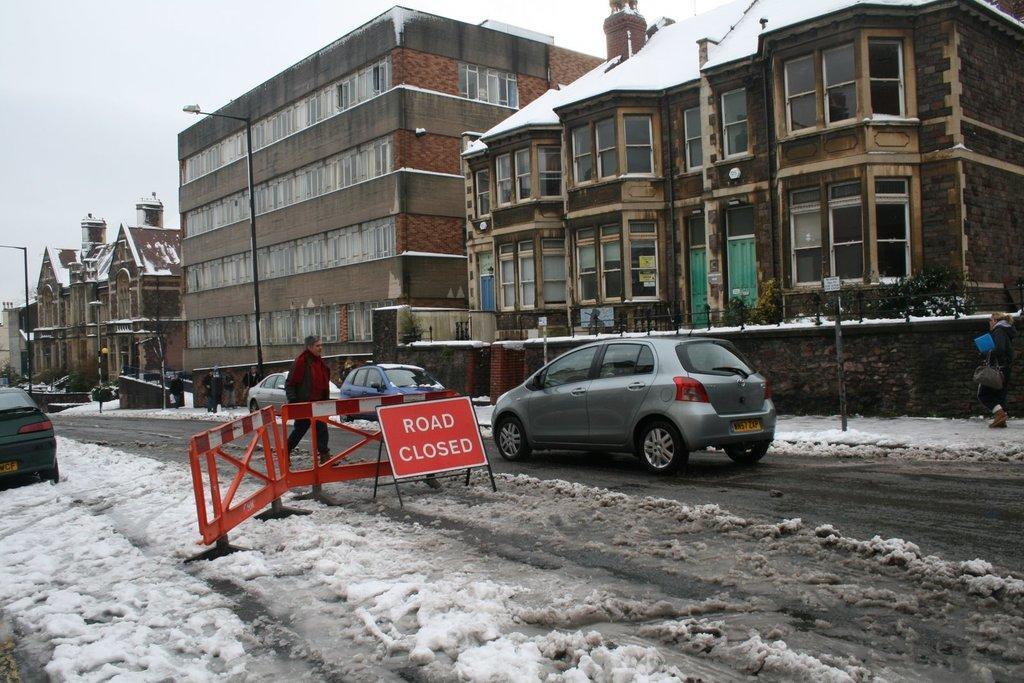Can you describe this image briefly? In this image there are buildings and poles. At the bottom there are cars on the road and we can see a board. There are people and we can see snow. In the background there is sky. 